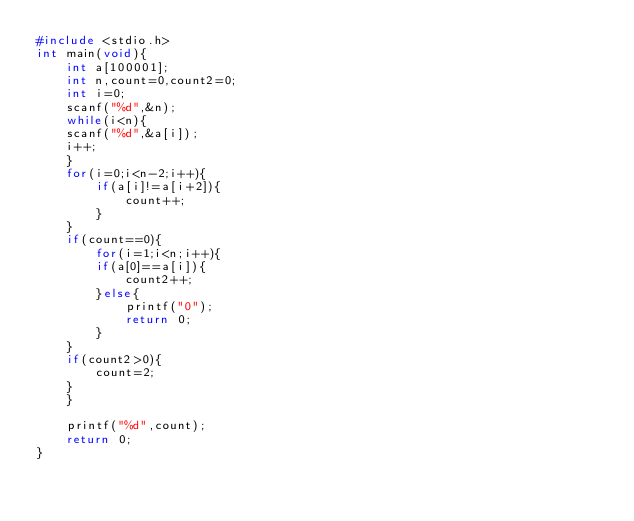Convert code to text. <code><loc_0><loc_0><loc_500><loc_500><_C_>#include <stdio.h>
int main(void){
    int a[100001];
    int n,count=0,count2=0;
    int i=0;
    scanf("%d",&n);
    while(i<n){
    scanf("%d",&a[i]);
    i++;
    }
    for(i=0;i<n-2;i++){
        if(a[i]!=a[i+2]){
            count++;
        }
    }
    if(count==0){
        for(i=1;i<n;i++){
        if(a[0]==a[i]){
            count2++;
        }else{
            printf("0");
            return 0;
        }
    }
    if(count2>0){
        count=2;
    }
    }
    
    printf("%d",count);
    return 0;
}</code> 